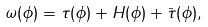Convert formula to latex. <formula><loc_0><loc_0><loc_500><loc_500>\omega ( \phi ) & = \tau ( \phi ) + H ( \phi ) + \bar { \tau } ( \phi ) ,</formula> 